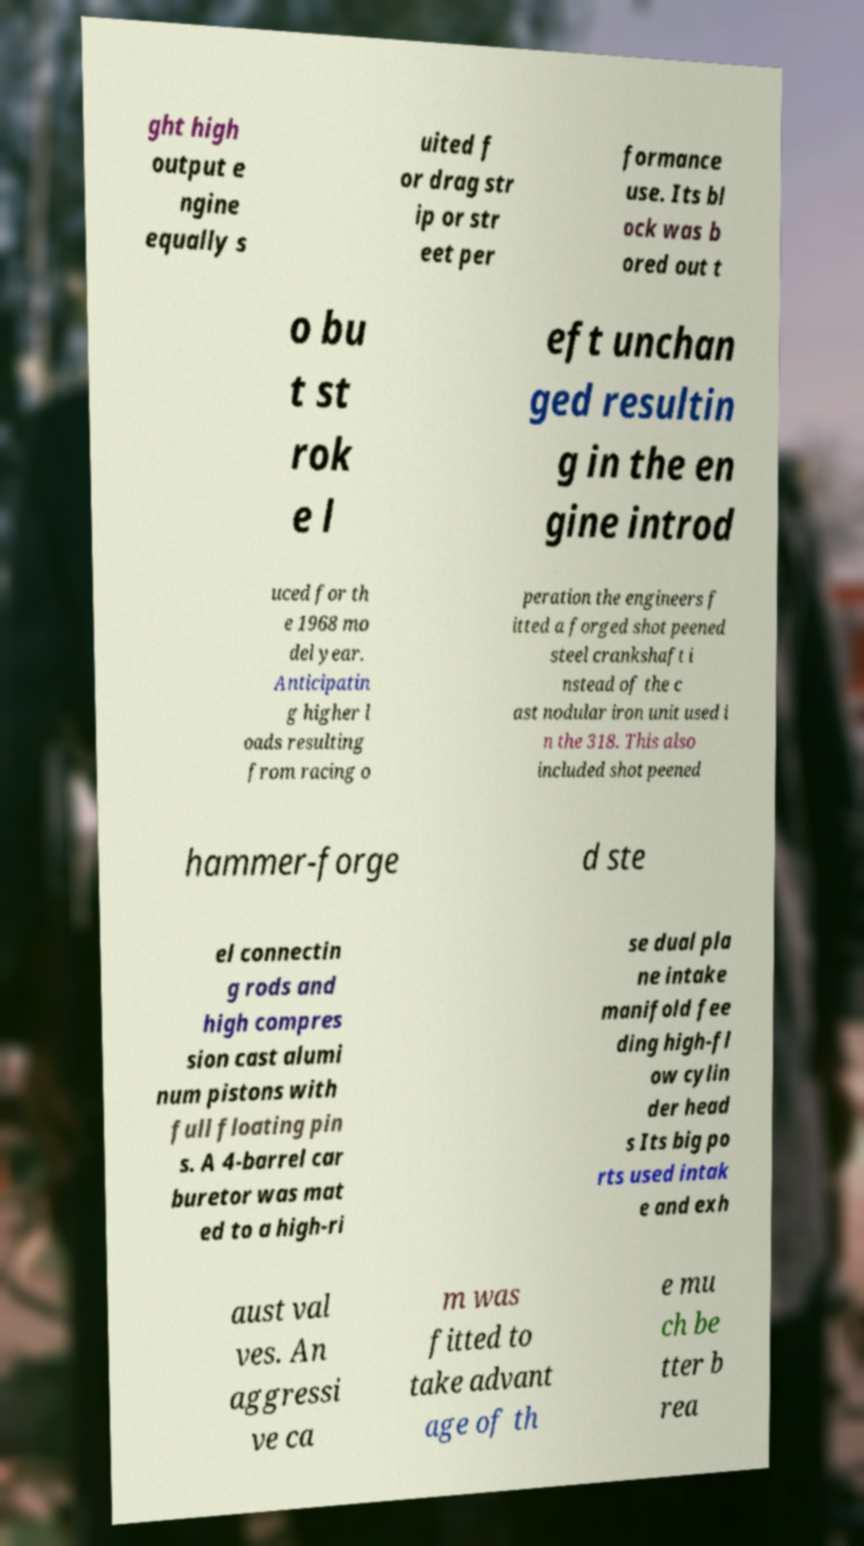Could you extract and type out the text from this image? ght high output e ngine equally s uited f or drag str ip or str eet per formance use. Its bl ock was b ored out t o bu t st rok e l eft unchan ged resultin g in the en gine introd uced for th e 1968 mo del year. Anticipatin g higher l oads resulting from racing o peration the engineers f itted a forged shot peened steel crankshaft i nstead of the c ast nodular iron unit used i n the 318. This also included shot peened hammer-forge d ste el connectin g rods and high compres sion cast alumi num pistons with full floating pin s. A 4-barrel car buretor was mat ed to a high-ri se dual pla ne intake manifold fee ding high-fl ow cylin der head s Its big po rts used intak e and exh aust val ves. An aggressi ve ca m was fitted to take advant age of th e mu ch be tter b rea 